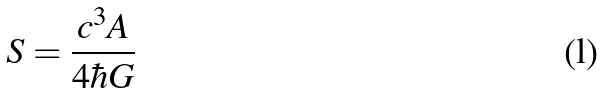<formula> <loc_0><loc_0><loc_500><loc_500>S = \frac { c ^ { 3 } A } { 4 \hbar { G } }</formula> 